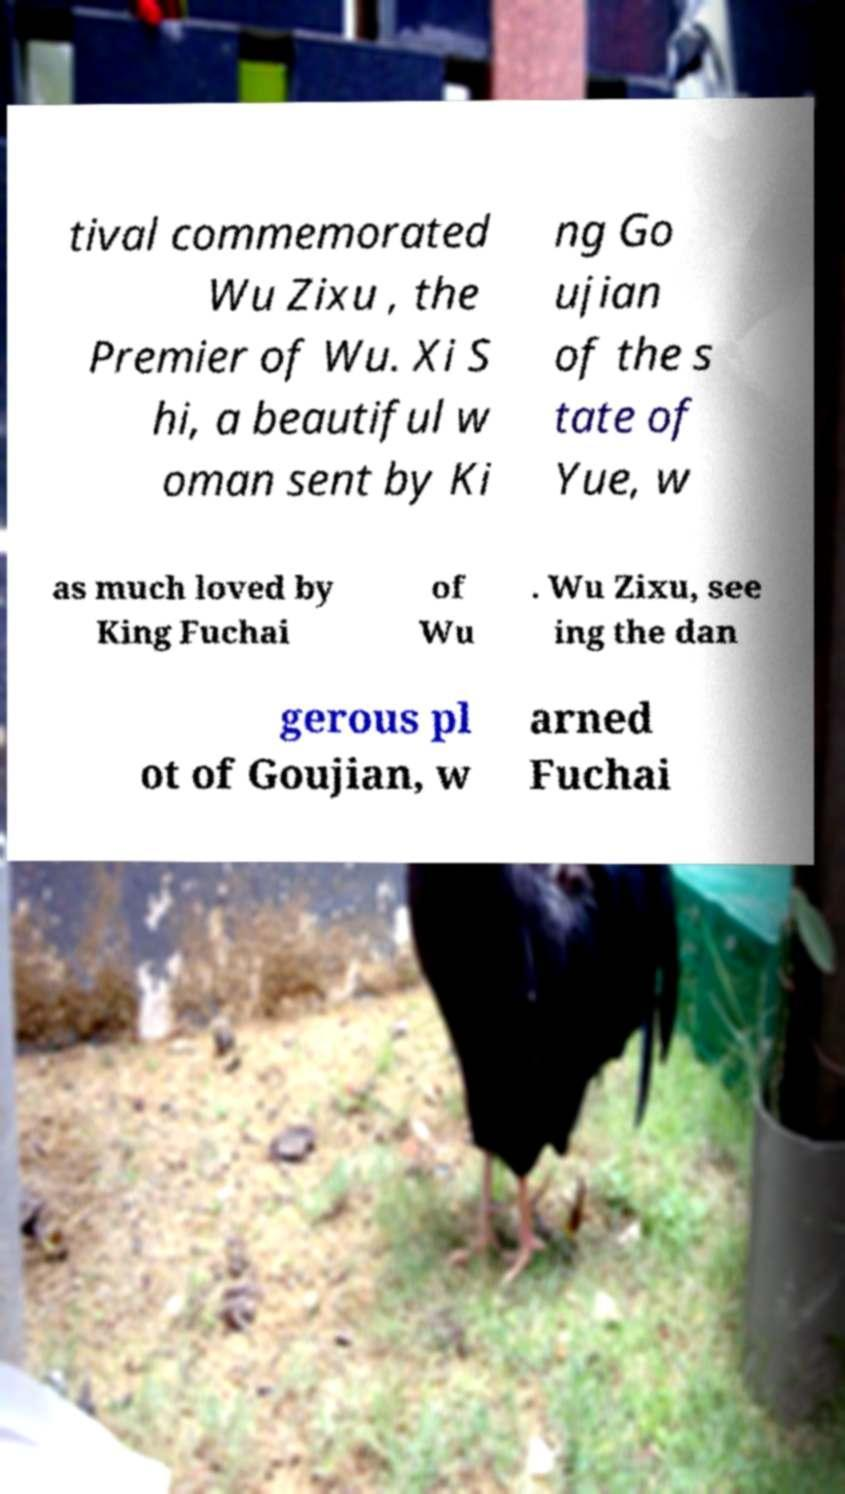What messages or text are displayed in this image? I need them in a readable, typed format. tival commemorated Wu Zixu , the Premier of Wu. Xi S hi, a beautiful w oman sent by Ki ng Go ujian of the s tate of Yue, w as much loved by King Fuchai of Wu . Wu Zixu, see ing the dan gerous pl ot of Goujian, w arned Fuchai 